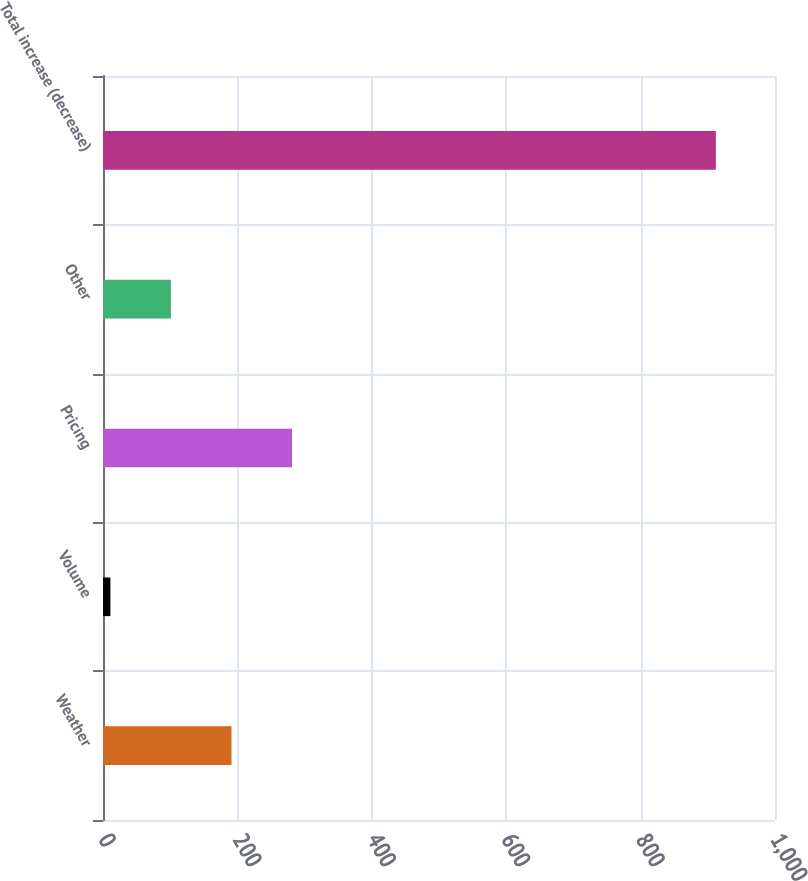<chart> <loc_0><loc_0><loc_500><loc_500><bar_chart><fcel>Weather<fcel>Volume<fcel>Pricing<fcel>Other<fcel>Total increase (decrease)<nl><fcel>191.2<fcel>11<fcel>281.3<fcel>101.1<fcel>912<nl></chart> 